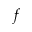<formula> <loc_0><loc_0><loc_500><loc_500>f</formula> 